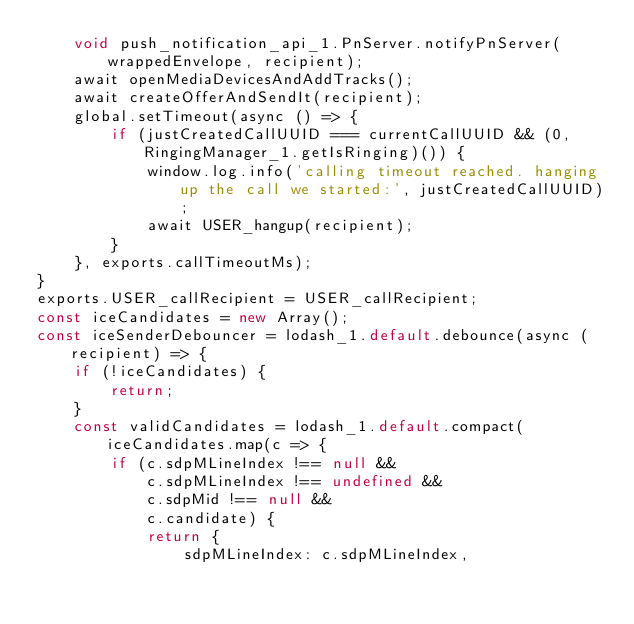Convert code to text. <code><loc_0><loc_0><loc_500><loc_500><_JavaScript_>    void push_notification_api_1.PnServer.notifyPnServer(wrappedEnvelope, recipient);
    await openMediaDevicesAndAddTracks();
    await createOfferAndSendIt(recipient);
    global.setTimeout(async () => {
        if (justCreatedCallUUID === currentCallUUID && (0, RingingManager_1.getIsRinging)()) {
            window.log.info('calling timeout reached. hanging up the call we started:', justCreatedCallUUID);
            await USER_hangup(recipient);
        }
    }, exports.callTimeoutMs);
}
exports.USER_callRecipient = USER_callRecipient;
const iceCandidates = new Array();
const iceSenderDebouncer = lodash_1.default.debounce(async (recipient) => {
    if (!iceCandidates) {
        return;
    }
    const validCandidates = lodash_1.default.compact(iceCandidates.map(c => {
        if (c.sdpMLineIndex !== null &&
            c.sdpMLineIndex !== undefined &&
            c.sdpMid !== null &&
            c.candidate) {
            return {
                sdpMLineIndex: c.sdpMLineIndex,</code> 